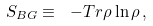<formula> <loc_0><loc_0><loc_500><loc_500>S _ { B G } \equiv \ - T r \rho \ln \rho \, ,</formula> 